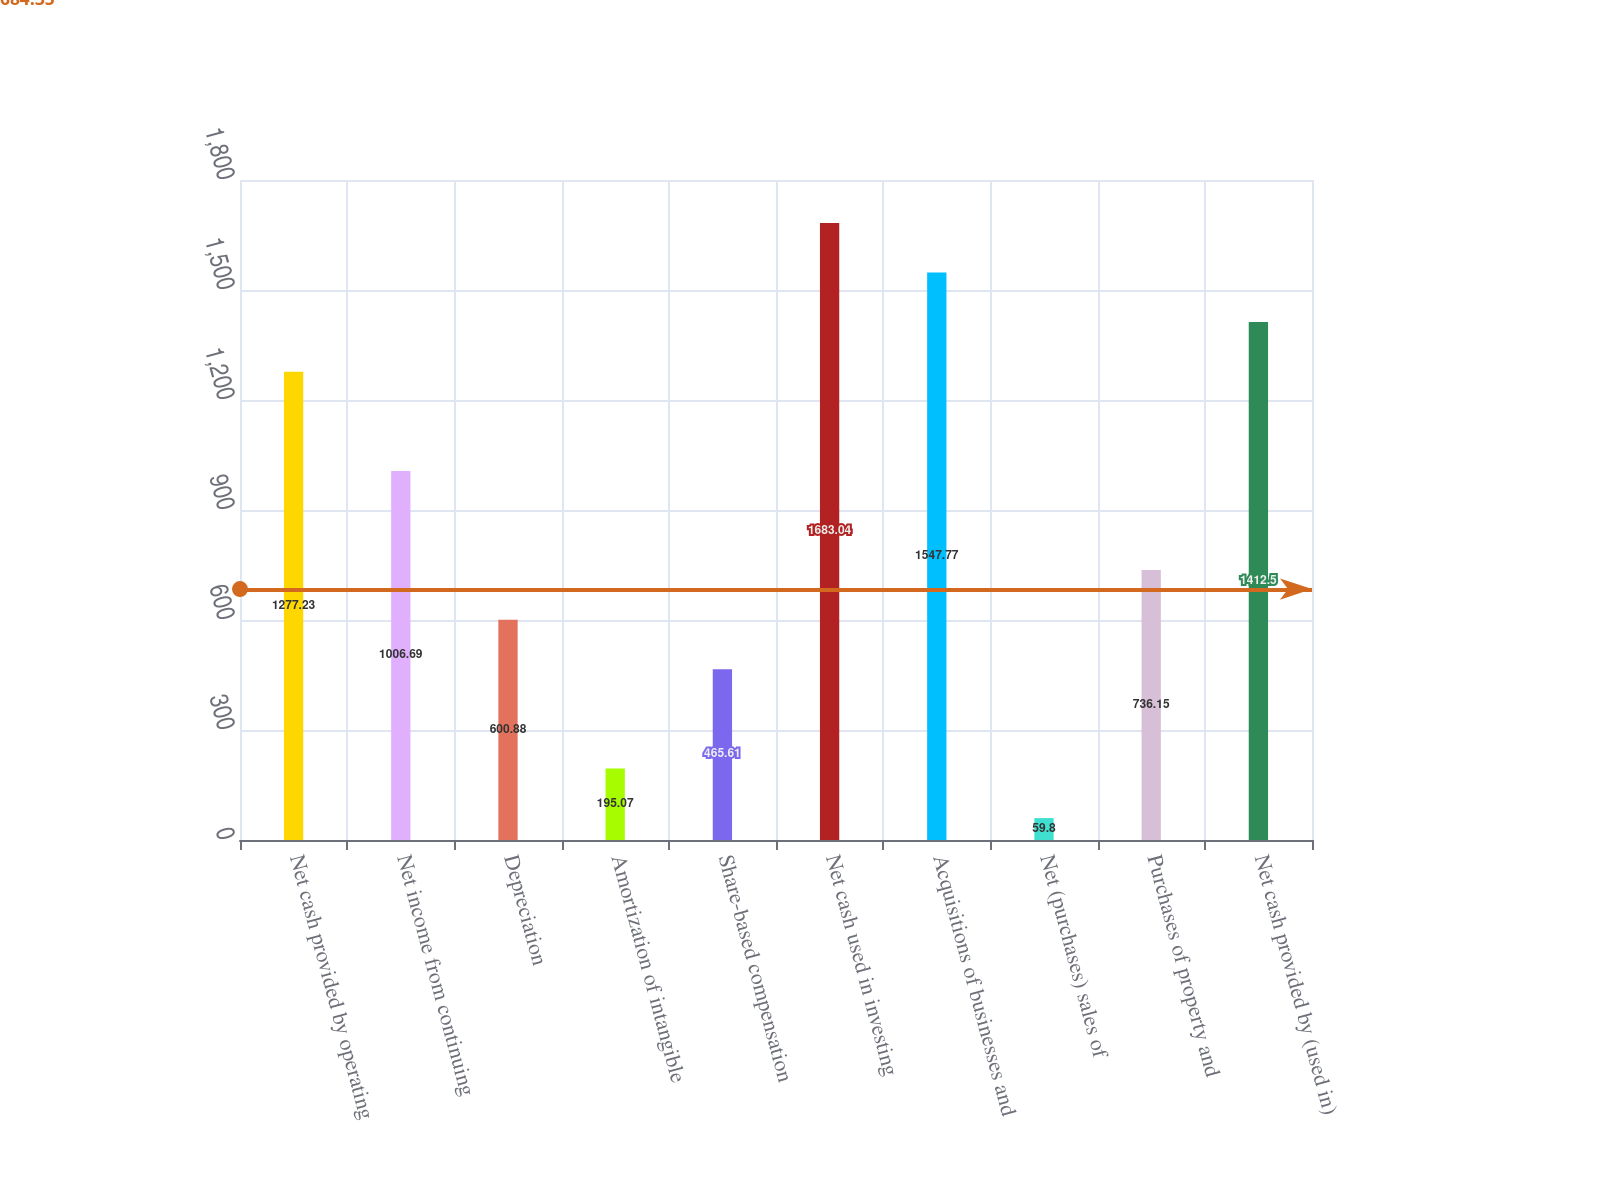<chart> <loc_0><loc_0><loc_500><loc_500><bar_chart><fcel>Net cash provided by operating<fcel>Net income from continuing<fcel>Depreciation<fcel>Amortization of intangible<fcel>Share-based compensation<fcel>Net cash used in investing<fcel>Acquisitions of businesses and<fcel>Net (purchases) sales of<fcel>Purchases of property and<fcel>Net cash provided by (used in)<nl><fcel>1277.23<fcel>1006.69<fcel>600.88<fcel>195.07<fcel>465.61<fcel>1683.04<fcel>1547.77<fcel>59.8<fcel>736.15<fcel>1412.5<nl></chart> 